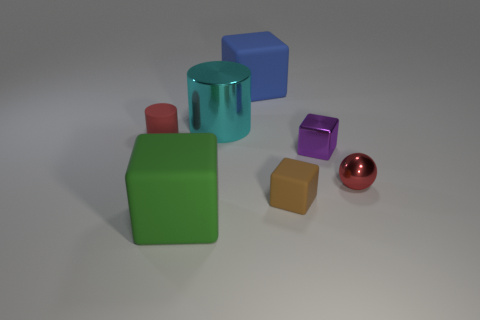What is the material of the object that is the same color as the small rubber cylinder?
Your answer should be compact. Metal. What number of metallic objects are purple things or small red balls?
Keep it short and to the point. 2. How big is the green matte block?
Ensure brevity in your answer.  Large. How many things are red objects or tiny red things that are left of the green cube?
Keep it short and to the point. 2. How many other things are the same color as the matte cylinder?
Give a very brief answer. 1. Do the cyan object and the matte block that is to the left of the blue rubber object have the same size?
Your answer should be compact. Yes. There is a cylinder to the right of the green object; does it have the same size as the small red metal object?
Keep it short and to the point. No. How many other things are the same material as the blue cube?
Provide a succinct answer. 3. Is the number of large rubber blocks to the right of the big cyan metal cylinder the same as the number of red metallic balls in front of the small rubber cylinder?
Ensure brevity in your answer.  Yes. The large object that is on the left side of the cylinder that is to the right of the red thing that is on the left side of the brown cube is what color?
Ensure brevity in your answer.  Green. 